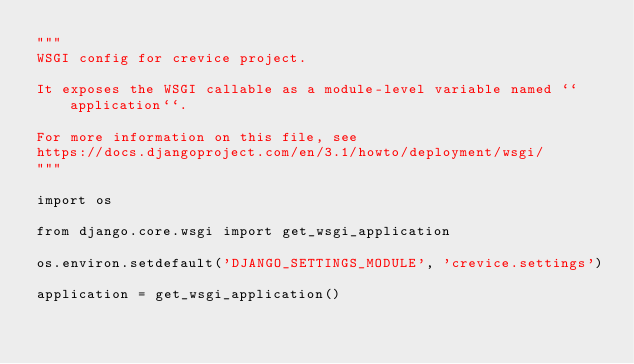<code> <loc_0><loc_0><loc_500><loc_500><_Python_>"""
WSGI config for crevice project.

It exposes the WSGI callable as a module-level variable named ``application``.

For more information on this file, see
https://docs.djangoproject.com/en/3.1/howto/deployment/wsgi/
"""

import os

from django.core.wsgi import get_wsgi_application

os.environ.setdefault('DJANGO_SETTINGS_MODULE', 'crevice.settings')

application = get_wsgi_application()
</code> 